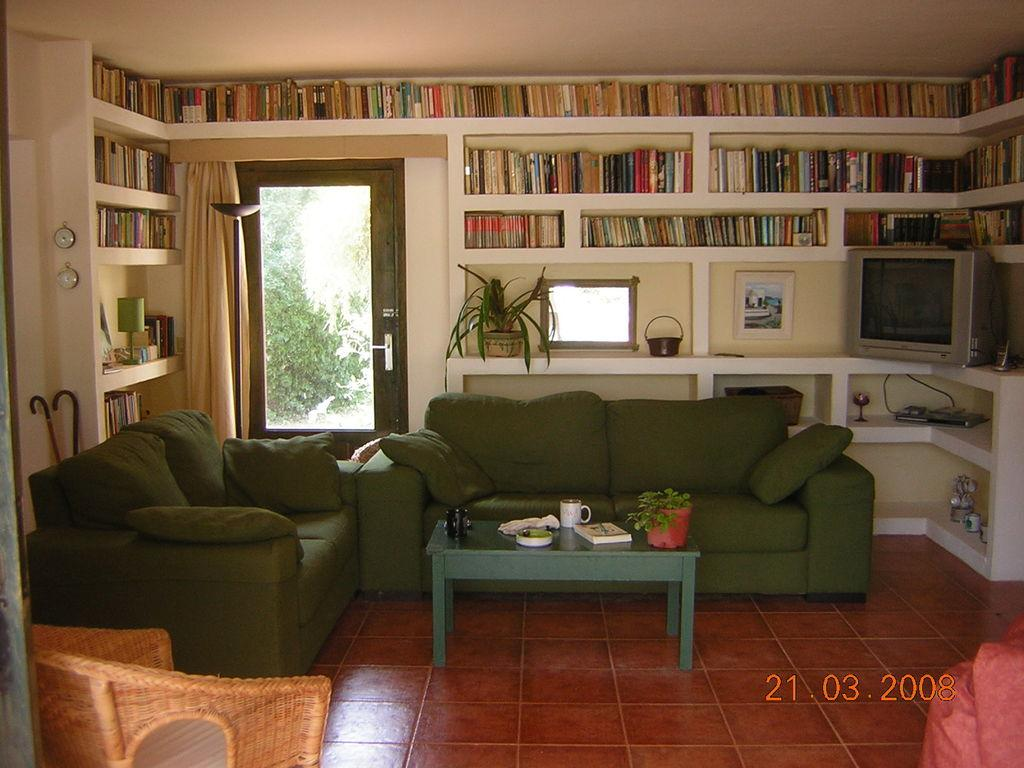What type of furniture is in the foreground of the image? There is a green sofa in the image. What is located in front of the sofa? There is a green table in front of the sofa. What can be seen in the background of the image? There is a bookshelf, a television, and a door in the background. What type of apparatus is being used to knit a sweater in the image? There is no apparatus or sweater present in the image. What is the need for the door in the background of the image? The purpose of the door in the background cannot be determined from the image alone, as it is not clear what the room is used for or what lies beyond the door. 